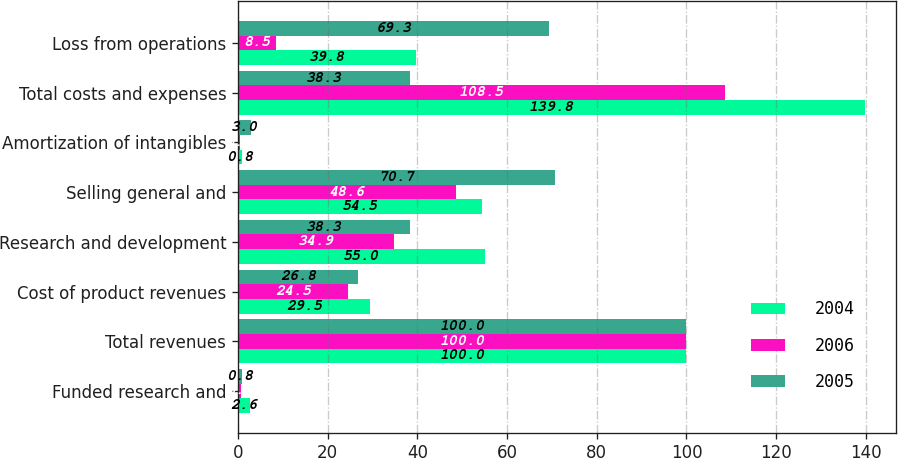Convert chart. <chart><loc_0><loc_0><loc_500><loc_500><stacked_bar_chart><ecel><fcel>Funded research and<fcel>Total revenues<fcel>Cost of product revenues<fcel>Research and development<fcel>Selling general and<fcel>Amortization of intangibles<fcel>Total costs and expenses<fcel>Loss from operations<nl><fcel>2004<fcel>2.6<fcel>100<fcel>29.5<fcel>55<fcel>54.5<fcel>0.8<fcel>139.8<fcel>39.8<nl><fcel>2006<fcel>0.7<fcel>100<fcel>24.5<fcel>34.9<fcel>48.6<fcel>0.5<fcel>108.5<fcel>8.5<nl><fcel>2005<fcel>0.8<fcel>100<fcel>26.8<fcel>38.3<fcel>70.7<fcel>3<fcel>38.3<fcel>69.3<nl></chart> 